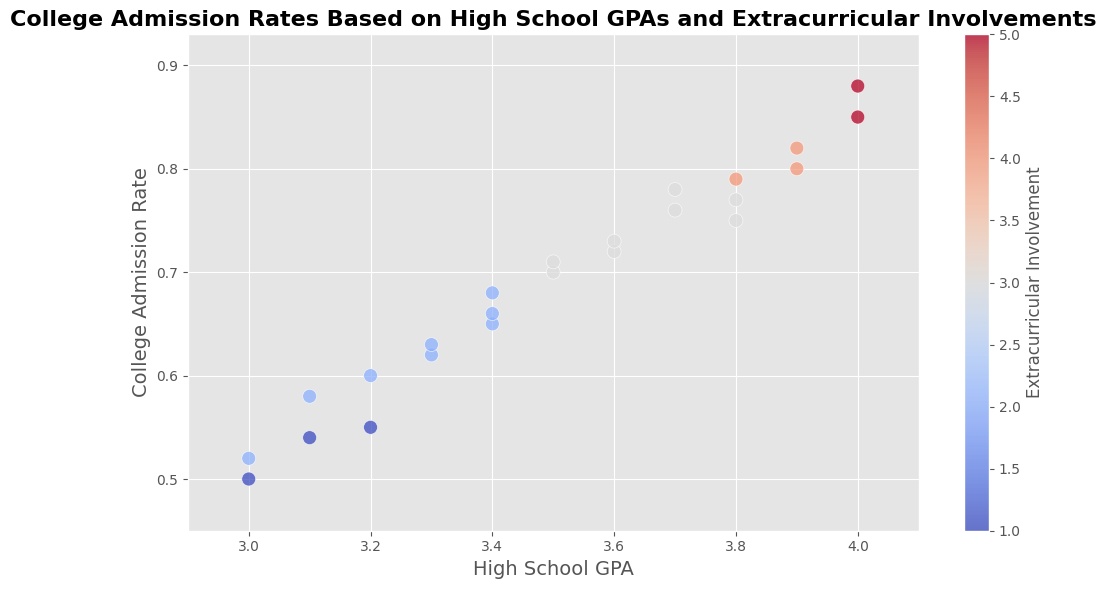What's the highest College Admission Rate for a student with an Extracurricular Involvement of 3? By visually inspecting the plot, look at the points marked with 3 on the color gradient (coolwarm implies somewhere in the middle range). The highest point on the y-axis among these should provide the answer.
Answer: 0.78 What's the overall trend between High School GPA and College Admission Rate? Observing the plot, as High School GPA increases (movement along the x-axis), College Admission Rate tends to increase (movement along the y-axis). This indicates a positive correlation between High School GPA and College Admission Rate.
Answer: Positive correlation How many students have a High School GPA of 4.0 and what are their College Admission Rates? Look at the points on the scatter plot aligned with a High School GPA of 4.0 on the x-axis. Identify and count these points and note their positions on the y-axis.
Answer: 2 students, with rates of 0.85 and 0.88 Which High School GPA has the lowest College Admission Rate and what is this rate? Identify the lowest point on the y-axis and trace it to the corresponding value on the x-axis (High School GPA).
Answer: 3.0, 0.50 What is the difference in College Admission Rate between the students with the highest High School GPA and those with one level lower? Find the College Admission Rates for students with a High School GPA of 4.0 and 3.9. For 4.0, the rates are 0.85 and 0.88, so we take an average: (0.85+0.88)/2 = 0.865. For 3.9, the rates are 0.80 and 0.82, so average is (0.80+0.82)/2 = 0.81. The difference is then 0.865 - 0.81.
Answer: 0.055 Do students with higher Extracurricular Involvement tend to have higher College Admission Rates? Consider points with the highest Extracurricular Involvement values (4 and 5 on color gradient) and observe their positions on the y-axis. High values on the y-axis indicate higher College Admission Rates, hence if these points are higher, the statement is likely true.
Answer: Yes What is the average College Admission Rate for students with a High School GPA of 3.8? Locate the points where High School GPA is 3.8 and find their College Admission Rates. Then calculate the average: (0.75 + 0.79 + 0.77)/3.
Answer: 0.77 How many students have an Extracurricular Involvement level of 1 and what are their College Admission Rates? Identify the points marked with an Extracurricular Involvement level of 1 on the color gradient. Count these points and note their positions on the y-axis for their College Admission Rates.
Answer: 3 students, with rates of 0.50, 0.55, and 0.54 What is the range of College Admission Rates for students with an Extracurricular Involvement level of 2? Find the minimum and maximum College Admission Rates for points colored to indicate an Extracurricular Involvement level of 2. The range is the difference between these two values.
Answer: 0.52 to 0.66 